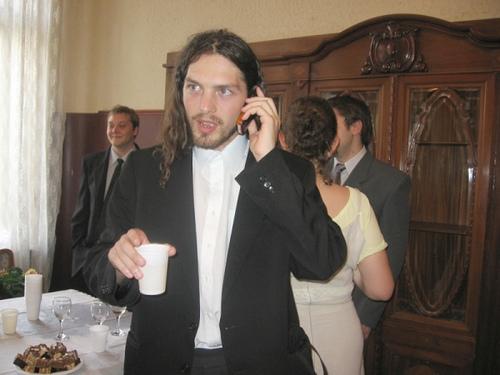Is this a party?
Write a very short answer. Yes. Are all the men wearing ties?
Short answer required. No. What is the man holding other than a cell phone?
Quick response, please. Cup. 